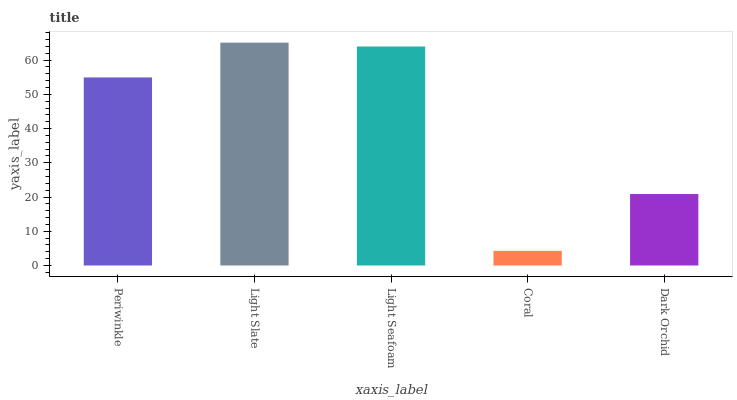Is Light Seafoam the minimum?
Answer yes or no. No. Is Light Seafoam the maximum?
Answer yes or no. No. Is Light Slate greater than Light Seafoam?
Answer yes or no. Yes. Is Light Seafoam less than Light Slate?
Answer yes or no. Yes. Is Light Seafoam greater than Light Slate?
Answer yes or no. No. Is Light Slate less than Light Seafoam?
Answer yes or no. No. Is Periwinkle the high median?
Answer yes or no. Yes. Is Periwinkle the low median?
Answer yes or no. Yes. Is Light Seafoam the high median?
Answer yes or no. No. Is Coral the low median?
Answer yes or no. No. 